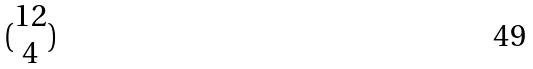Convert formula to latex. <formula><loc_0><loc_0><loc_500><loc_500>( \begin{matrix} 1 2 \\ 4 \end{matrix} )</formula> 